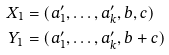Convert formula to latex. <formula><loc_0><loc_0><loc_500><loc_500>X _ { 1 } & = ( a _ { 1 } ^ { \prime } , \dots , a _ { k } ^ { \prime } , b , c ) \\ Y _ { 1 } & = ( a _ { 1 } ^ { \prime } , \dots , a _ { k } ^ { \prime } , b + c )</formula> 